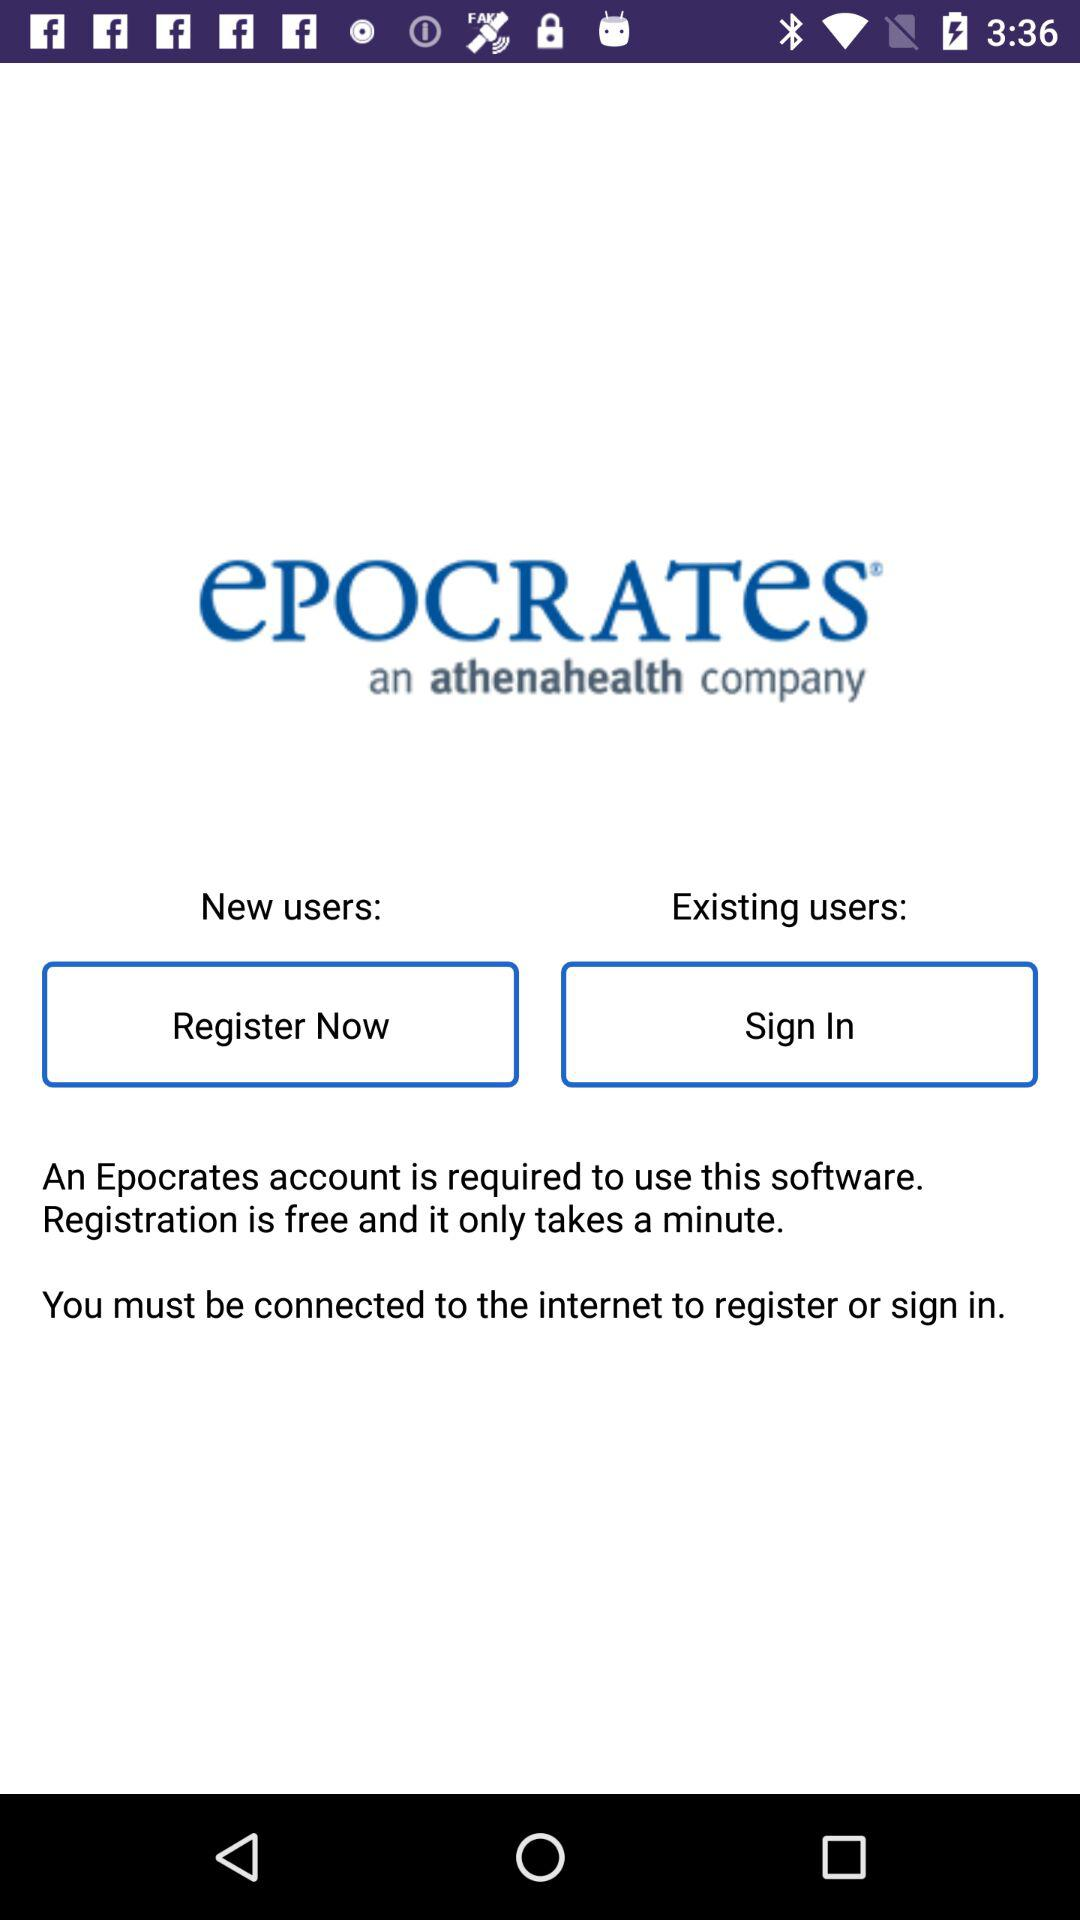What account is required to use this software? The account that is required to use this software is "Epocrates". 